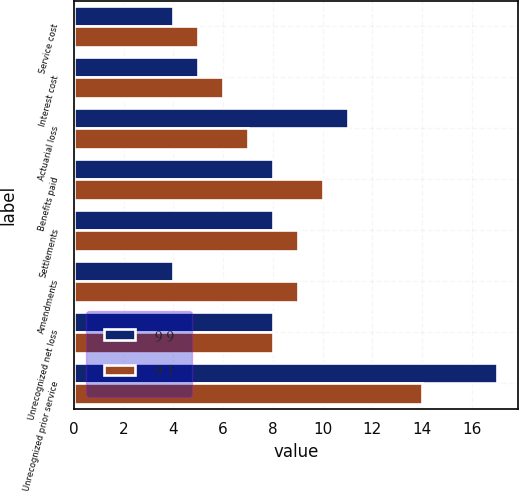<chart> <loc_0><loc_0><loc_500><loc_500><stacked_bar_chart><ecel><fcel>Service cost<fcel>Interest cost<fcel>Actuarial loss<fcel>Benefits paid<fcel>Settlements<fcel>Amendments<fcel>Unrecognized net loss<fcel>Unrecognized prior service<nl><fcel>9 9<fcel>4<fcel>5<fcel>11<fcel>8<fcel>8<fcel>4<fcel>8<fcel>17<nl><fcel>9 1<fcel>5<fcel>6<fcel>7<fcel>10<fcel>9<fcel>9<fcel>8<fcel>14<nl></chart> 